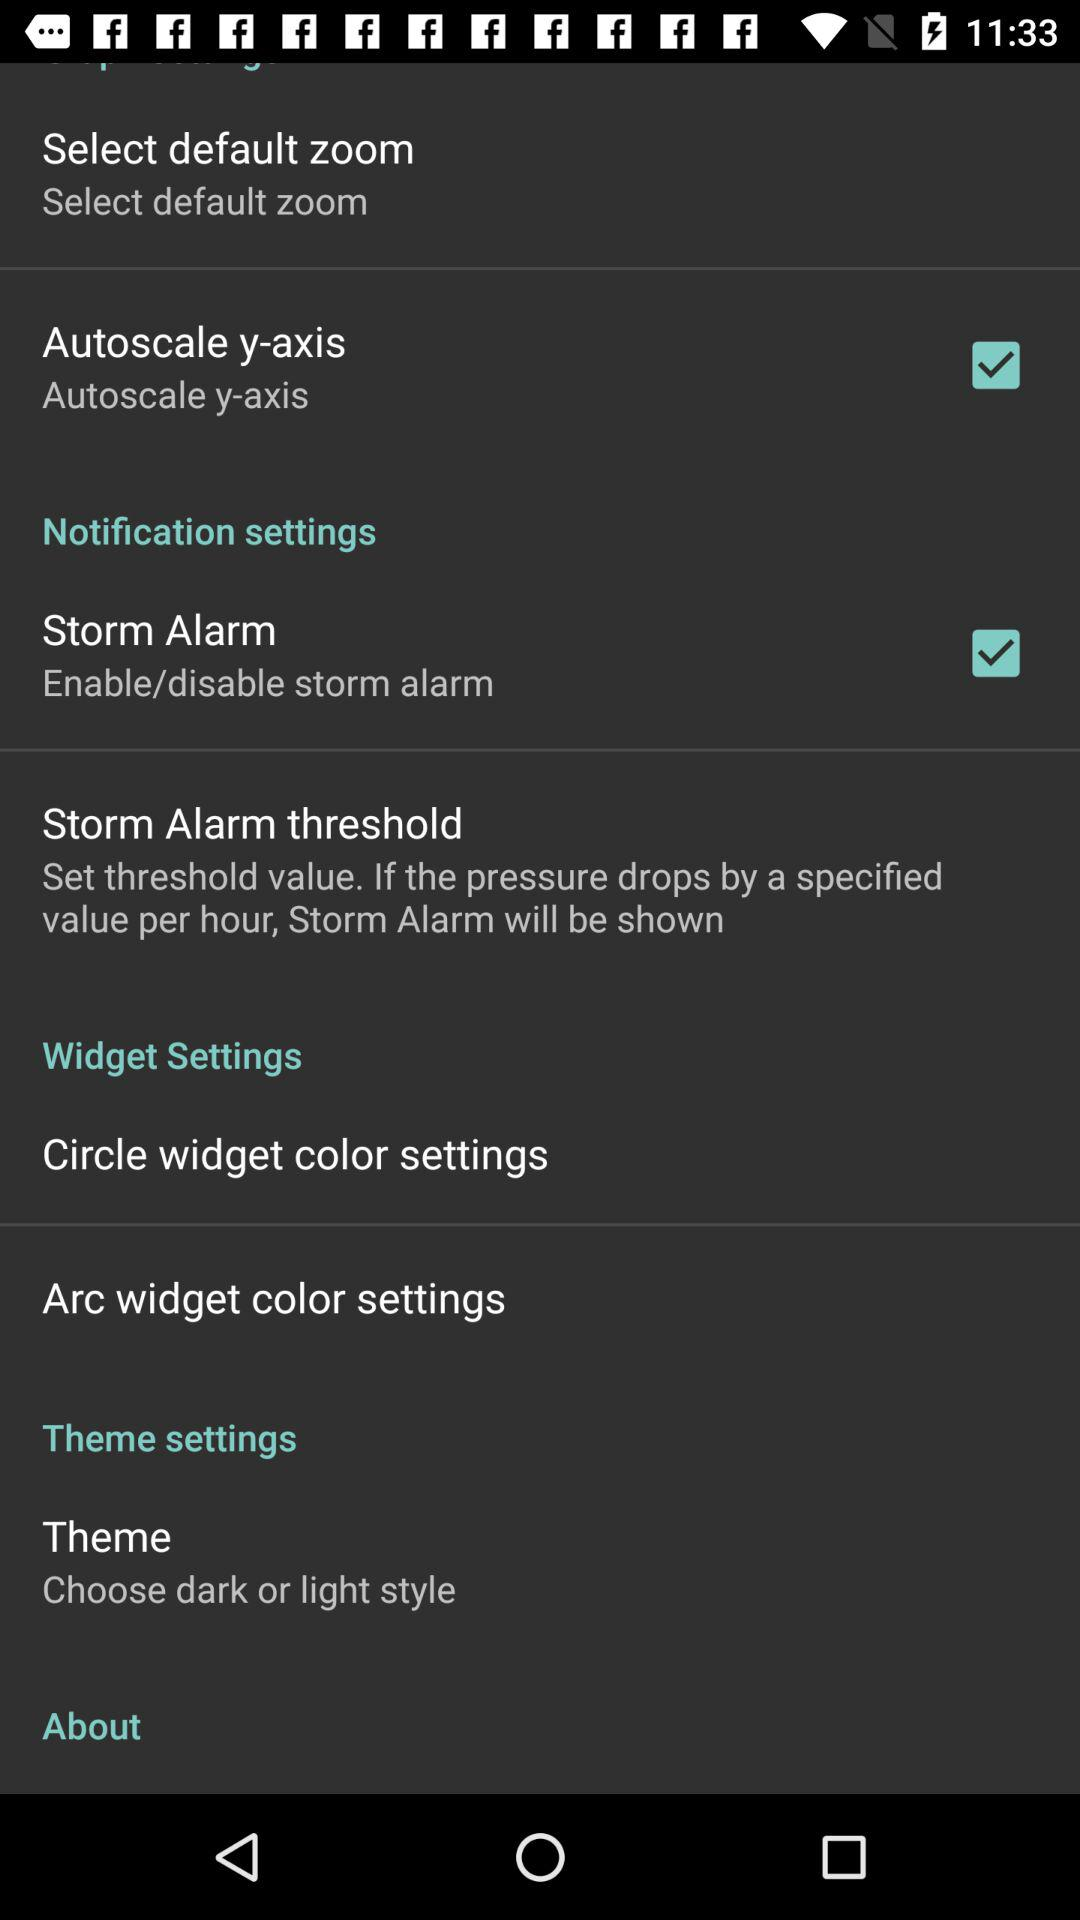How many items are in the theme settings section?
Answer the question using a single word or phrase. 2 